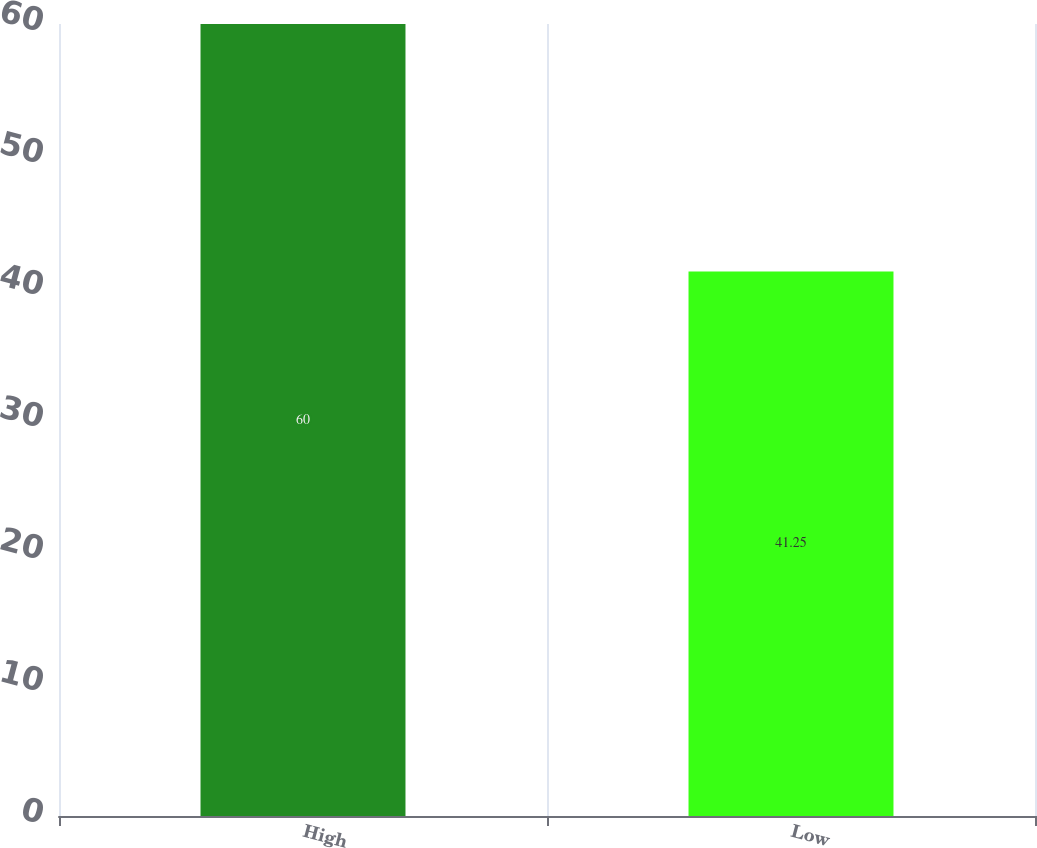<chart> <loc_0><loc_0><loc_500><loc_500><bar_chart><fcel>High<fcel>Low<nl><fcel>60<fcel>41.25<nl></chart> 